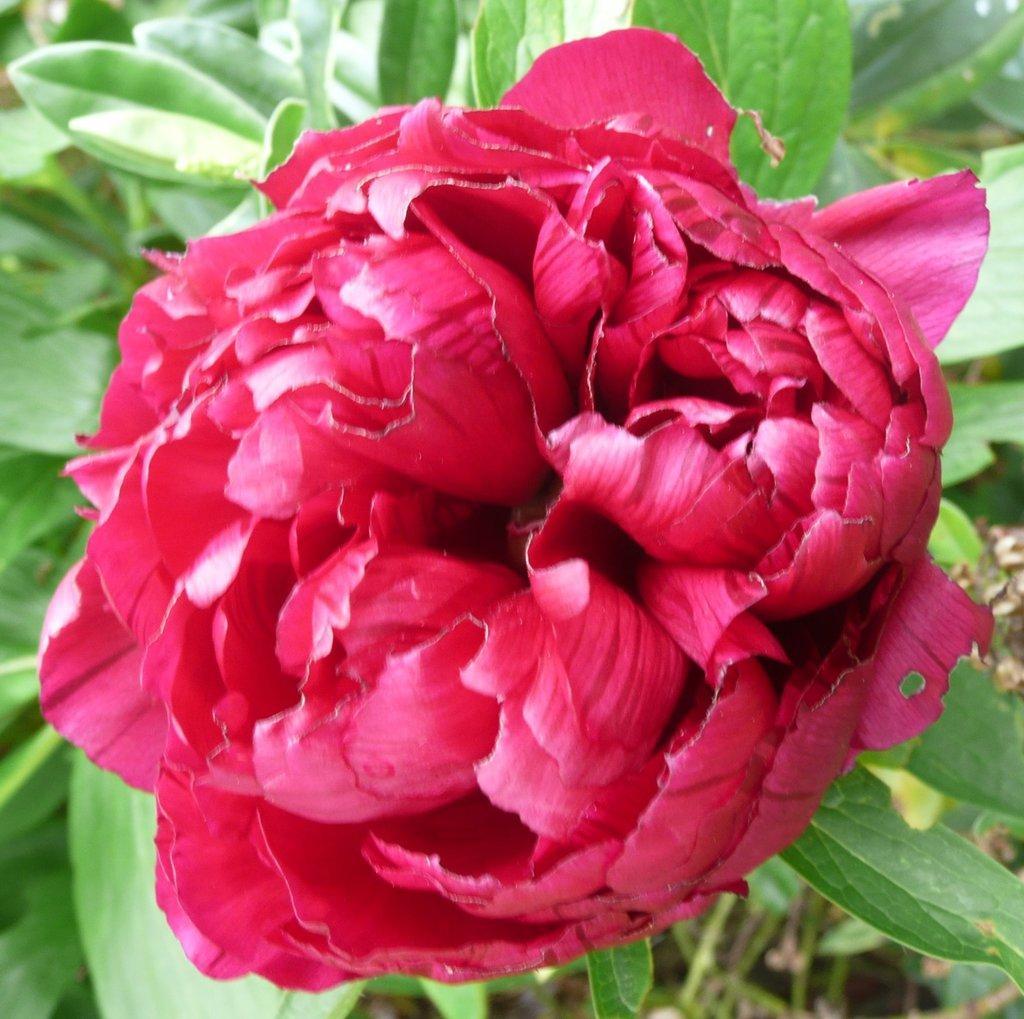How would you summarize this image in a sentence or two? In this image there is a flower, at the background of the image there is a plant. 